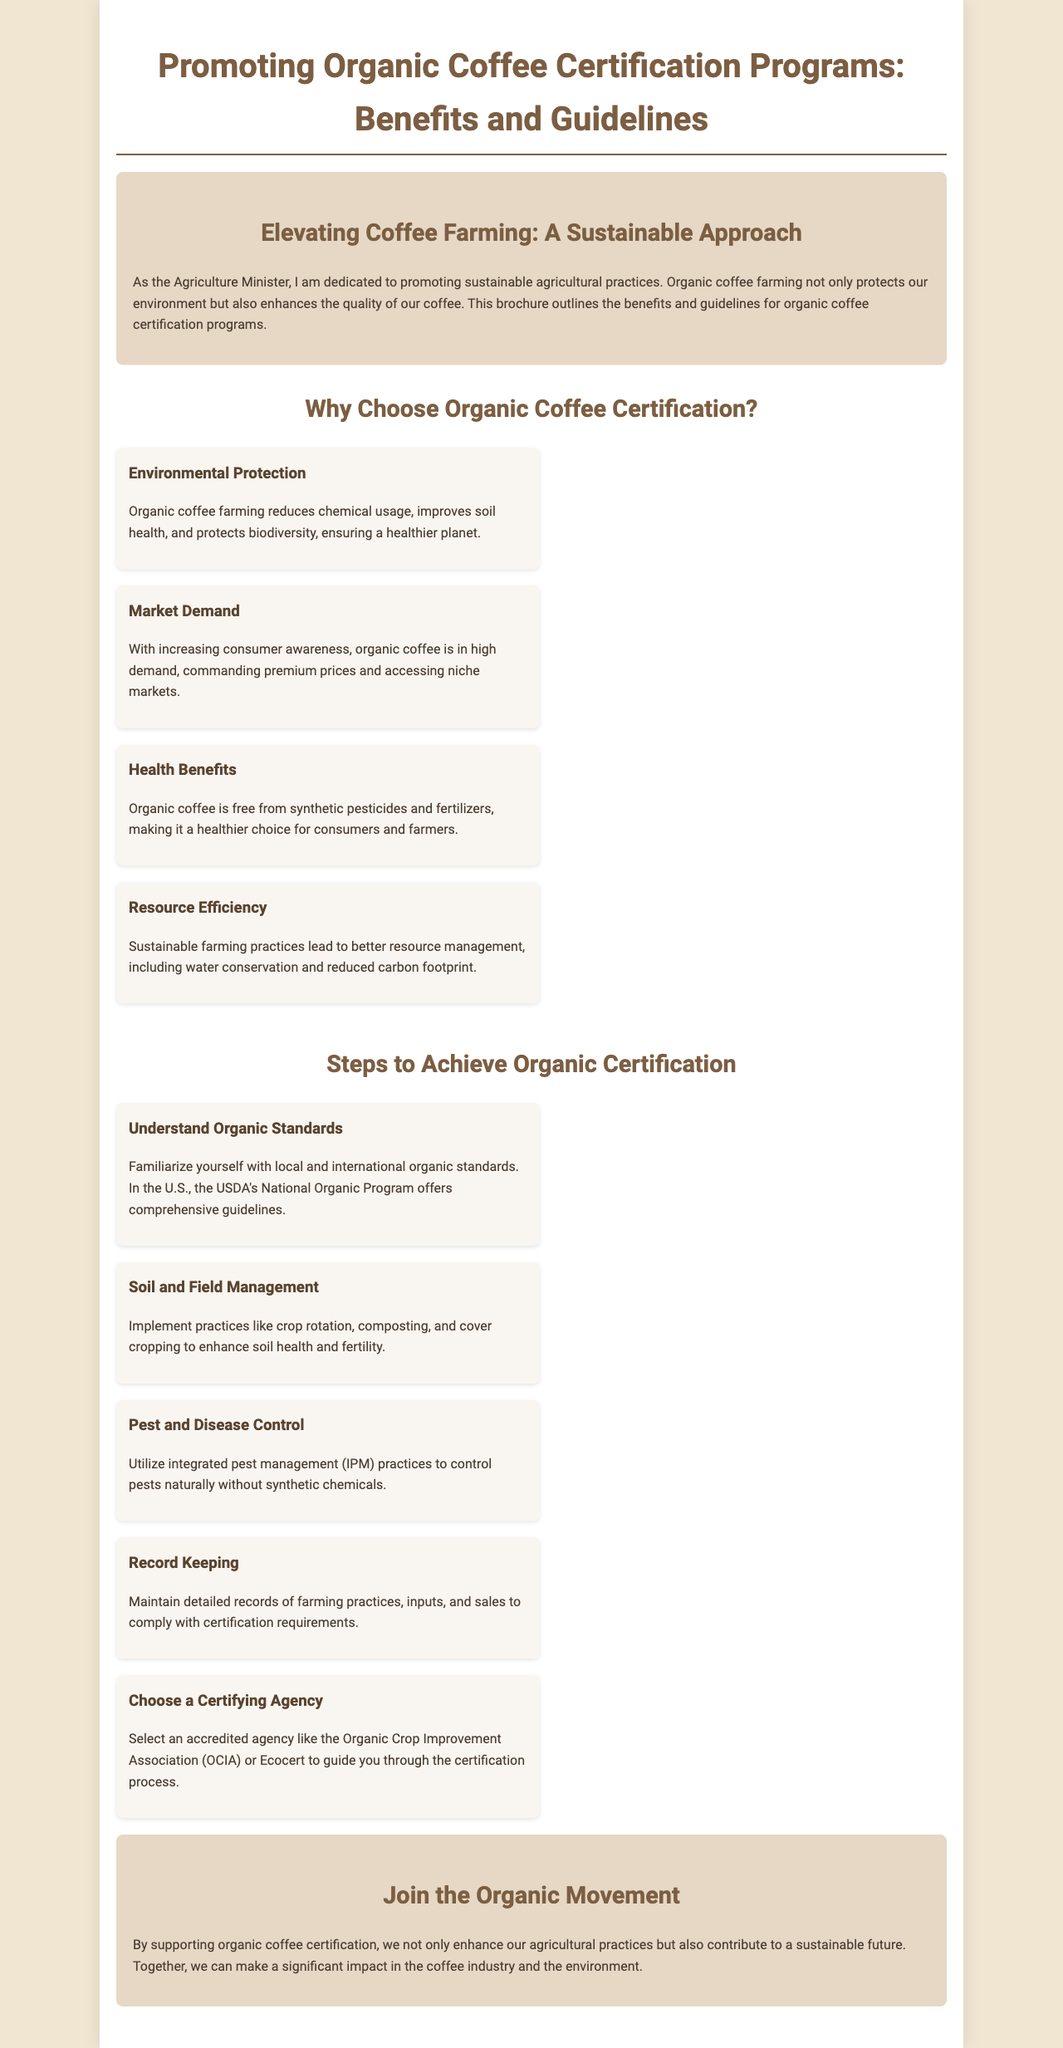What is the title of the brochure? The title is found at the top of the document, introducing the main topic.
Answer: Promoting Organic Coffee Certification Programs: Benefits and Guidelines What is one key environmental benefit of organic coffee farming? The document lists environmental advantages, highlighting important aspects of organic farming.
Answer: Environmental Protection What does organic coffee farming reduce in terms of chemical usage? The brochure explains the impact of organic farming on chemical substances, providing a specific context.
Answer: Synthetic pesticides What agency can farmers choose for certification? The guidelines section specifies accredited agencies for farmers seeking certification.
Answer: Organic Crop Improvement Association What practice can enhance soil health in organic coffee farming? The document discusses specific practices under soil management that lead to improved soil quality.
Answer: Crop rotation How many benefits of organic coffee certification are listed? The brochure outlines distinct benefits that show support for organic certifications.
Answer: Four What is the main purpose of the brochure? The introduction provides insight into the overall aim of the document.
Answer: Promoting sustainable agricultural practices What is one step in achieving organic certification? The guidelines section provides multiple steps necessary for farmers to gain certification.
Answer: Record Keeping Who is dedicated to promoting sustainable agricultural practices? The introductory message identifies an individual responsible for the promotion of these practices.
Answer: Agriculture Minister 